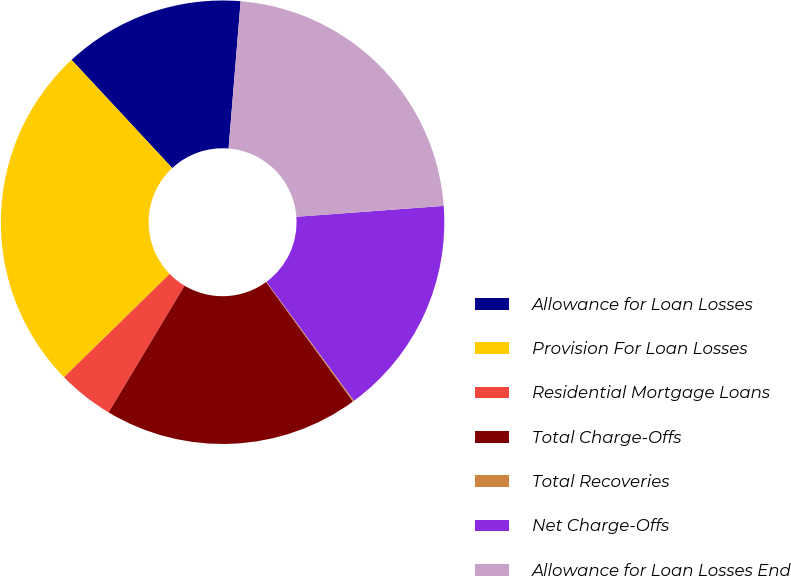<chart> <loc_0><loc_0><loc_500><loc_500><pie_chart><fcel>Allowance for Loan Losses<fcel>Provision For Loan Losses<fcel>Residential Mortgage Loans<fcel>Total Charge-Offs<fcel>Total Recoveries<fcel>Net Charge-Offs<fcel>Allowance for Loan Losses End<nl><fcel>13.22%<fcel>25.39%<fcel>4.09%<fcel>18.6%<fcel>0.09%<fcel>16.07%<fcel>22.53%<nl></chart> 